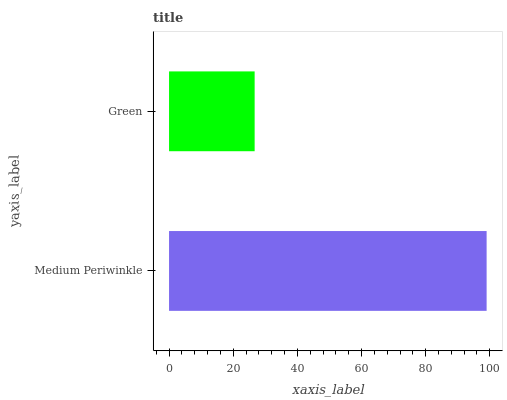Is Green the minimum?
Answer yes or no. Yes. Is Medium Periwinkle the maximum?
Answer yes or no. Yes. Is Green the maximum?
Answer yes or no. No. Is Medium Periwinkle greater than Green?
Answer yes or no. Yes. Is Green less than Medium Periwinkle?
Answer yes or no. Yes. Is Green greater than Medium Periwinkle?
Answer yes or no. No. Is Medium Periwinkle less than Green?
Answer yes or no. No. Is Medium Periwinkle the high median?
Answer yes or no. Yes. Is Green the low median?
Answer yes or no. Yes. Is Green the high median?
Answer yes or no. No. Is Medium Periwinkle the low median?
Answer yes or no. No. 